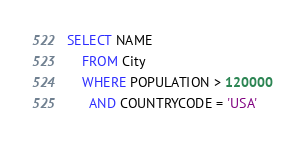<code> <loc_0><loc_0><loc_500><loc_500><_SQL_>SELECT NAME
    FROM City
    WHERE POPULATION > 120000
      AND COUNTRYCODE = 'USA'</code> 